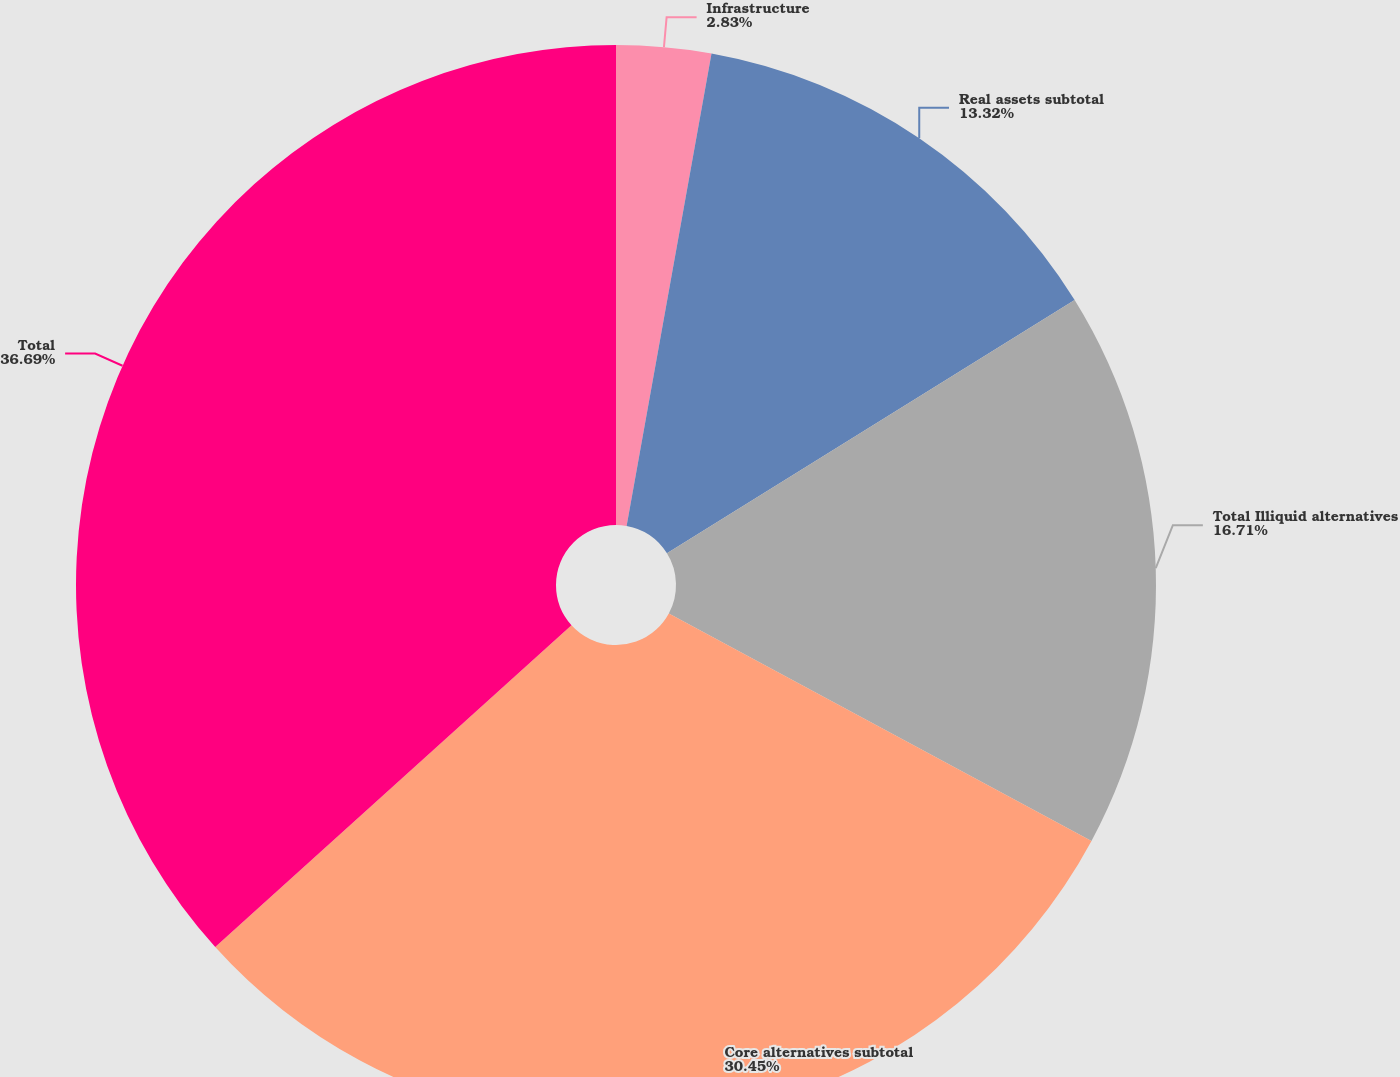<chart> <loc_0><loc_0><loc_500><loc_500><pie_chart><fcel>Infrastructure<fcel>Real assets subtotal<fcel>Total Illiquid alternatives<fcel>Core alternatives subtotal<fcel>Total<nl><fcel>2.83%<fcel>13.32%<fcel>16.71%<fcel>30.45%<fcel>36.69%<nl></chart> 